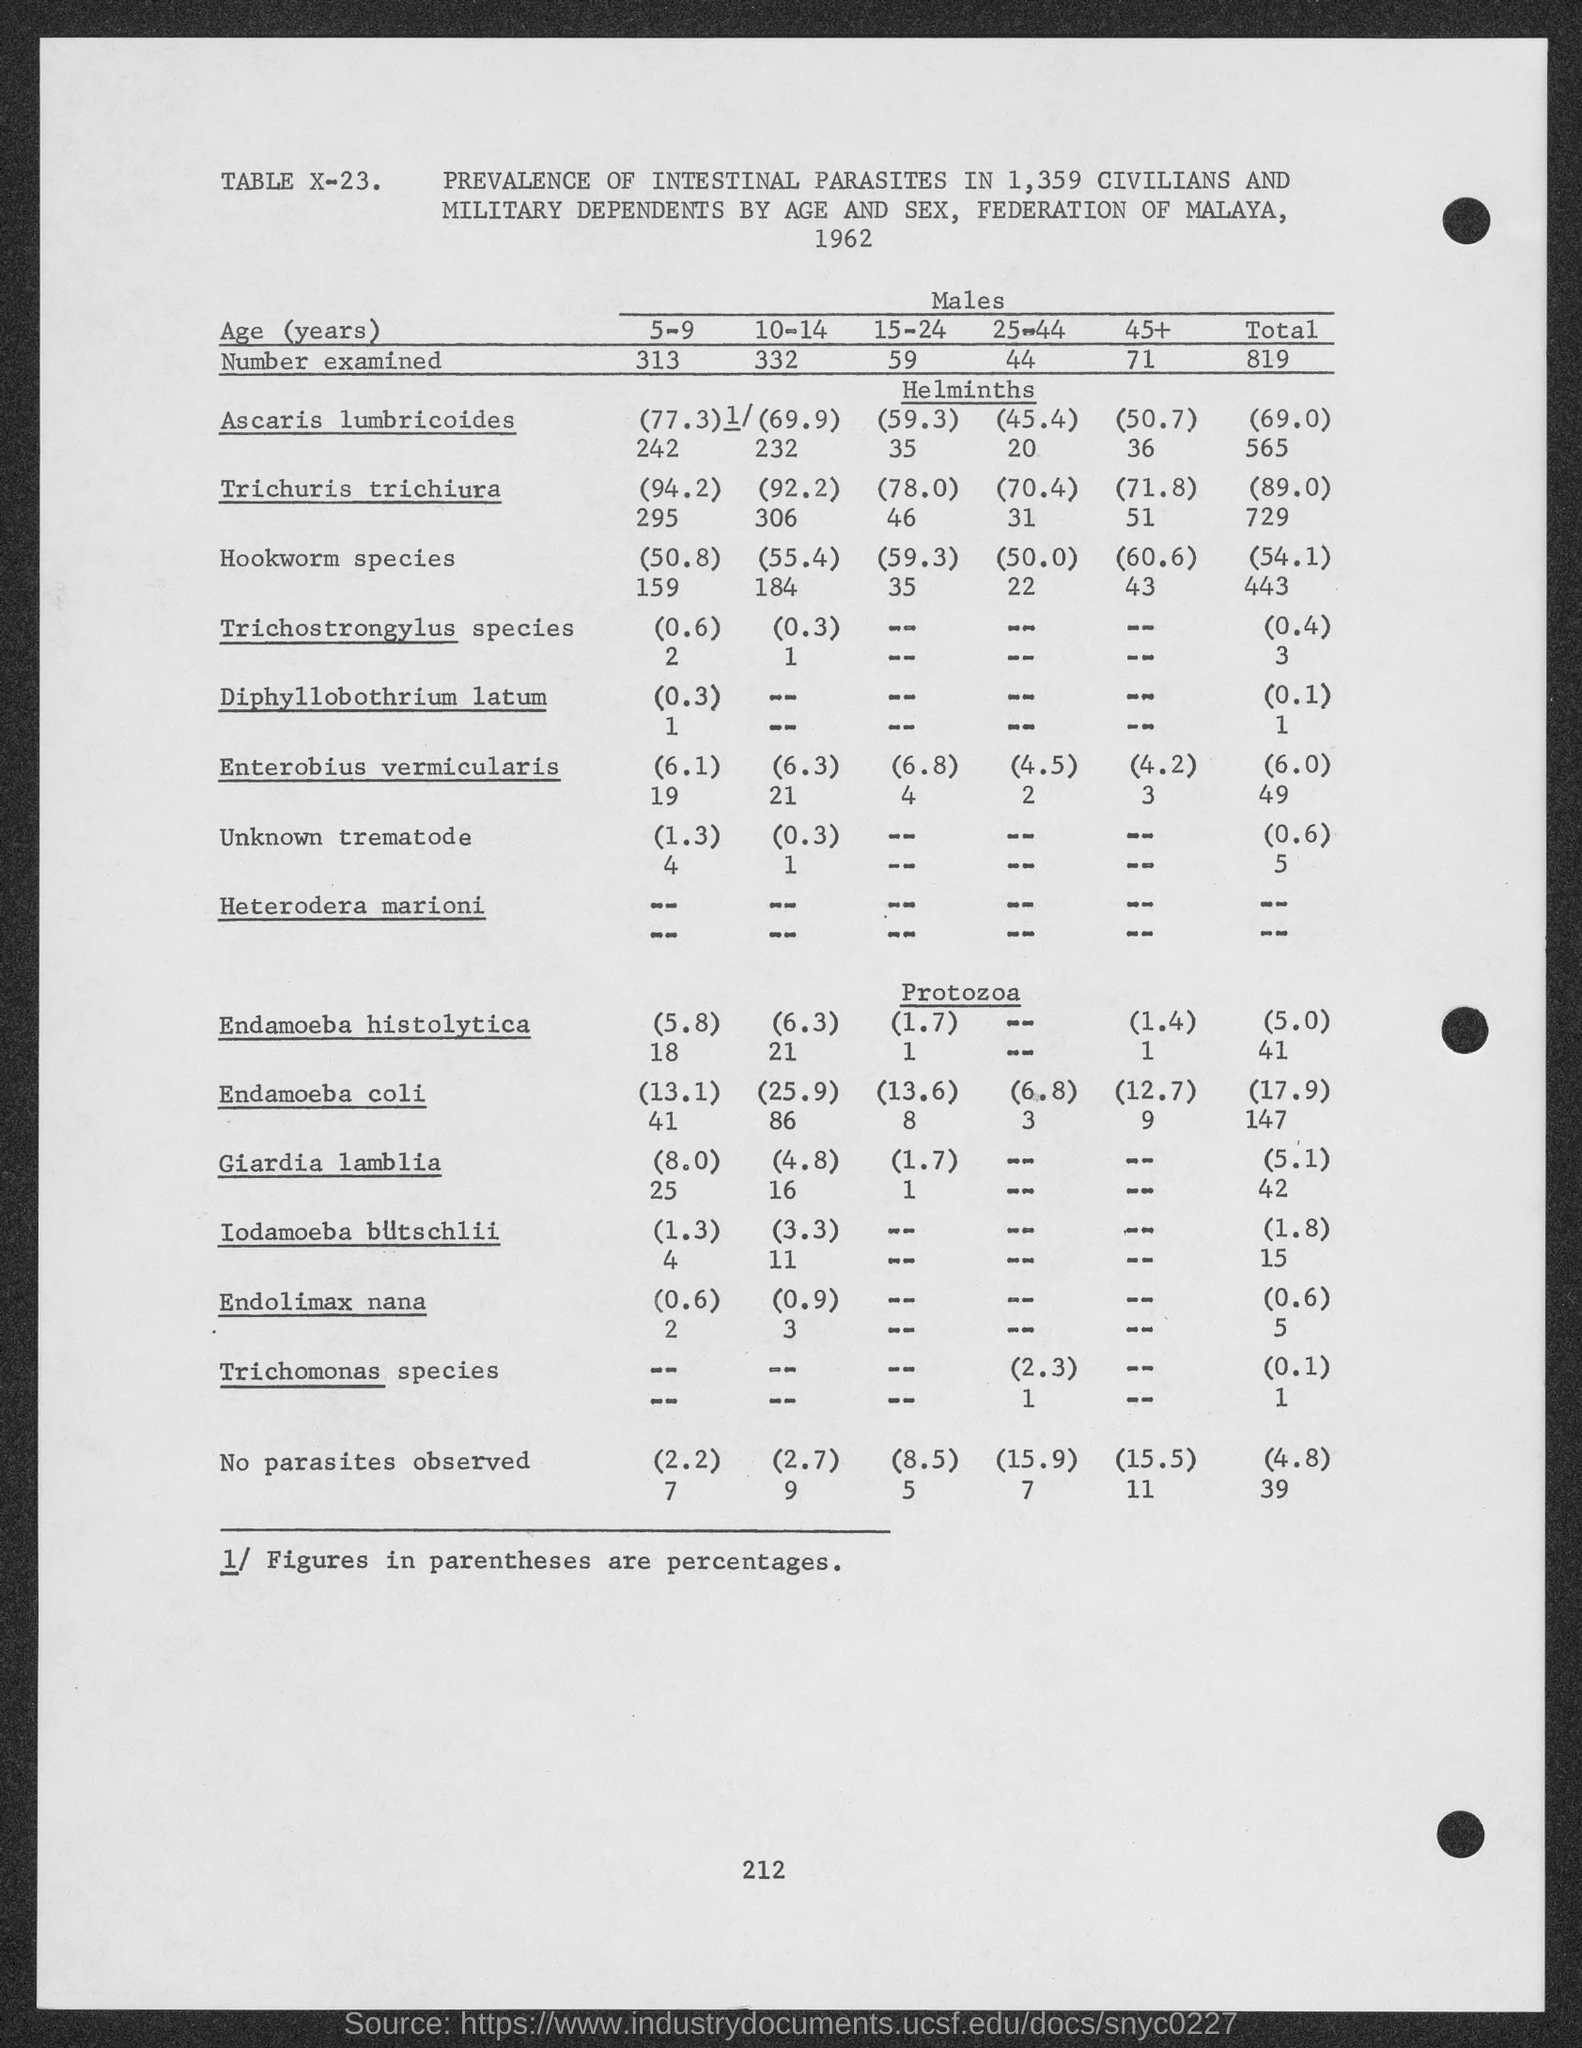List a handful of essential elements in this visual. Giardia lamblia is classified under the heading of Protozoa. The study was conducted in 1962. The table number indicated at the top of the table is X-23. In total, 819 males were examined. A total of 54.1% of hookworm species were present in the sample. 